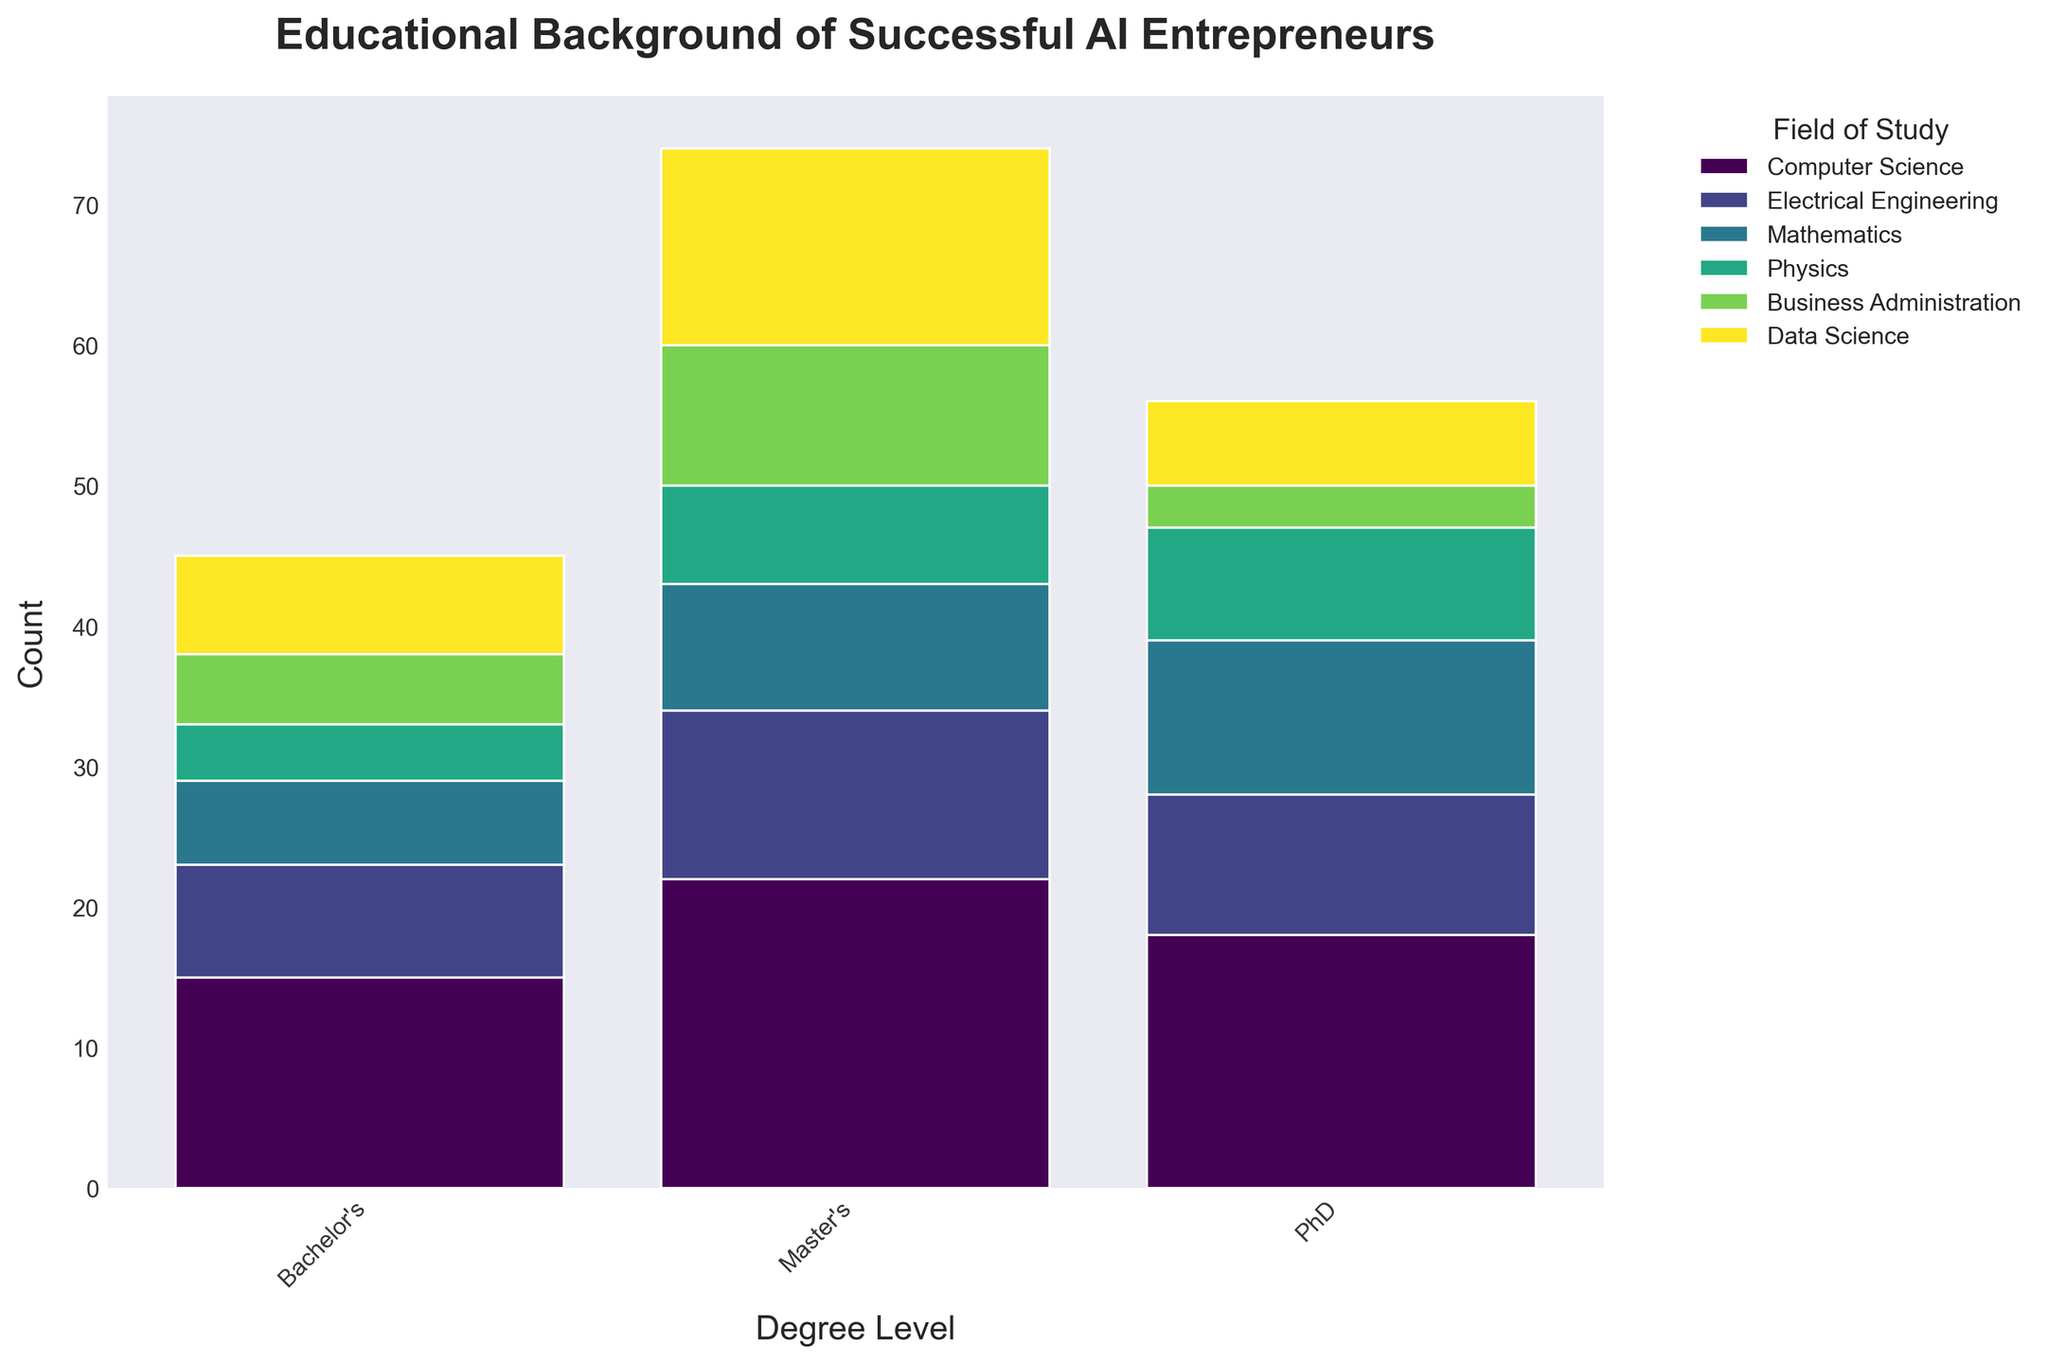What is the title of the plotted figure? The title of the figure is usually at the top of the plot and provides a concise description of what the figure is about. In this case, the title is "Educational Background of Successful AI Entrepreneurs."
Answer: Educational Background of Successful AI Entrepreneurs Which field of study has the highest representation at the Master's degree level? To determine this, examine the bars corresponding to the Master's degree level and see which one is the tallest. In this case, the bar for Computer Science at the Master's level is the tallest.
Answer: Computer Science How many total successful AI entrepreneurs have a PhD degree in Data Science? Locate the section of the bars representing PhD degrees, identify the segment for Data Science, and read the count. Here, there are 6 individuals with a PhD in Data Science.
Answer: 6 What is the total count of successful AI entrepreneurs with a Master's degree in Mathematics and Physics? Add the count of entrepreneurs with a Master's degree in Mathematics and Physics. For Mathematics, the count is 9, and for Physics, it is 7. The total is 9 + 7, which equals 16.
Answer: 16 Which degree level has the least representation in Business Administration? For Business Administration, compare the heights of the bars for different degree levels. The PhD level has the least representation with a count of 3.
Answer: PhD How does the number of successful AI entrepreneurs with a Bachelor's degree in Electrical Engineering compare to those with a Master's degree in Computer Science? Compare the height of the bar for Bachelor's degree in Electrical Engineering (8) with the bar for Master's degree in Computer Science (22). The Master's degree in Computer Science has a higher count.
Answer: Master's in Computer Science has a higher count Which field of study has the smallest total representation across all degree levels? Sum the counts for all degree levels for each field of study and compare. Physics has a total of 4 + 7 + 8 = 19, which is the smallest among the fields.
Answer: Physics What is the most common degree level among successful AI entrepreneurs in the dataset? Determine this by summing the counts for each degree level across all fields of study and compare the totals. The Master's degree level has the highest overall count.
Answer: Master's degree level How does the representation of successful AI entrepreneurs with a PhD degree in Computer Science compare to those with a Bachelor's degree in Computer Science? Compare the height of the bar for PhD in Computer Science (18) with Bachelor's in Computer Science (15). The PhD degree representation is higher.
Answer: PhD degree in Computer Science What is the combined representation of successful AI entrepreneurs with Bachelor's degrees in Business Administration and Data Science? Add the count of entrepreneurs with Bachelor's degrees in Business Administration (5) and Data Science (7). The combined count is 5 + 7, which equals 12.
Answer: 12 